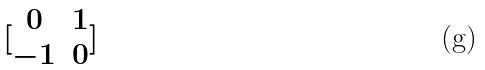Convert formula to latex. <formula><loc_0><loc_0><loc_500><loc_500>[ \begin{matrix} 0 & 1 \\ - 1 & 0 \end{matrix} ]</formula> 